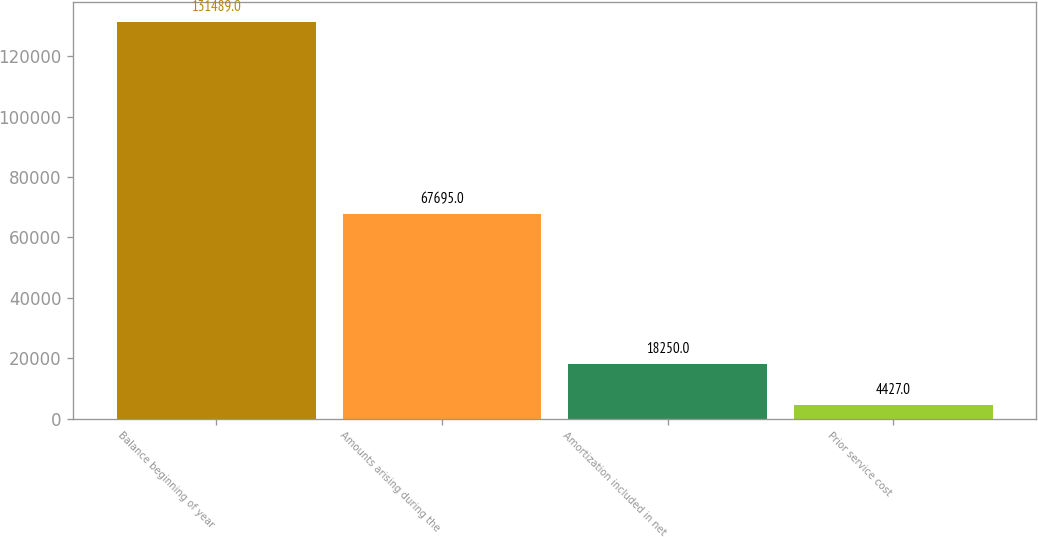<chart> <loc_0><loc_0><loc_500><loc_500><bar_chart><fcel>Balance beginning of year<fcel>Amounts arising during the<fcel>Amortization included in net<fcel>Prior service cost<nl><fcel>131489<fcel>67695<fcel>18250<fcel>4427<nl></chart> 